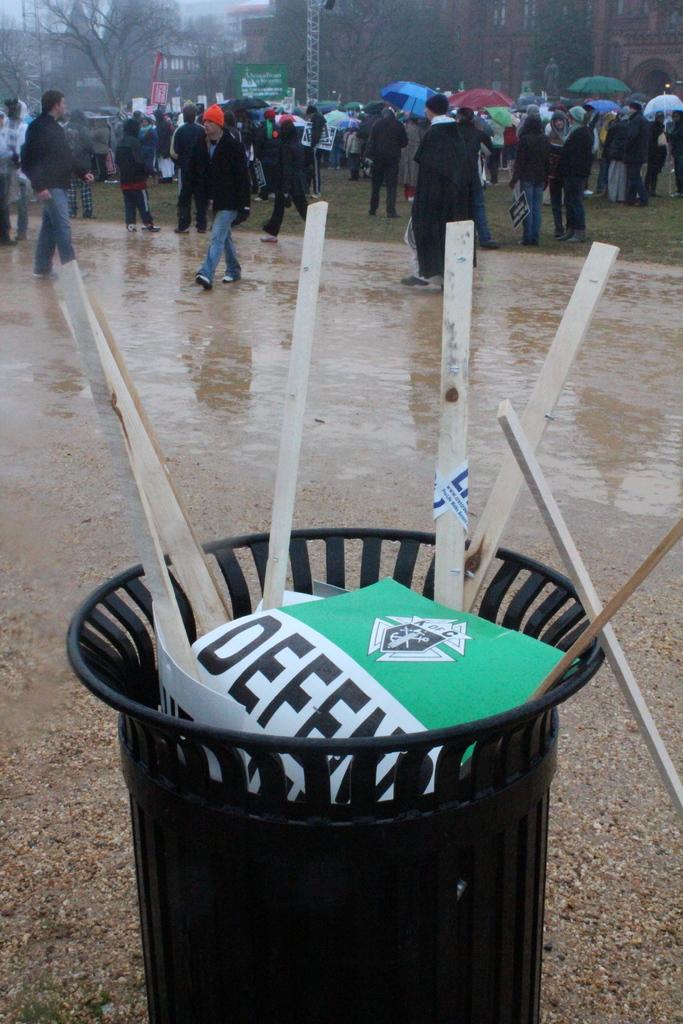Did someone throw a sign in the trashcan?
Provide a short and direct response. Answering does not require reading text in the image. What does it say on the green part of the banner?
Offer a very short reply. Defend. 